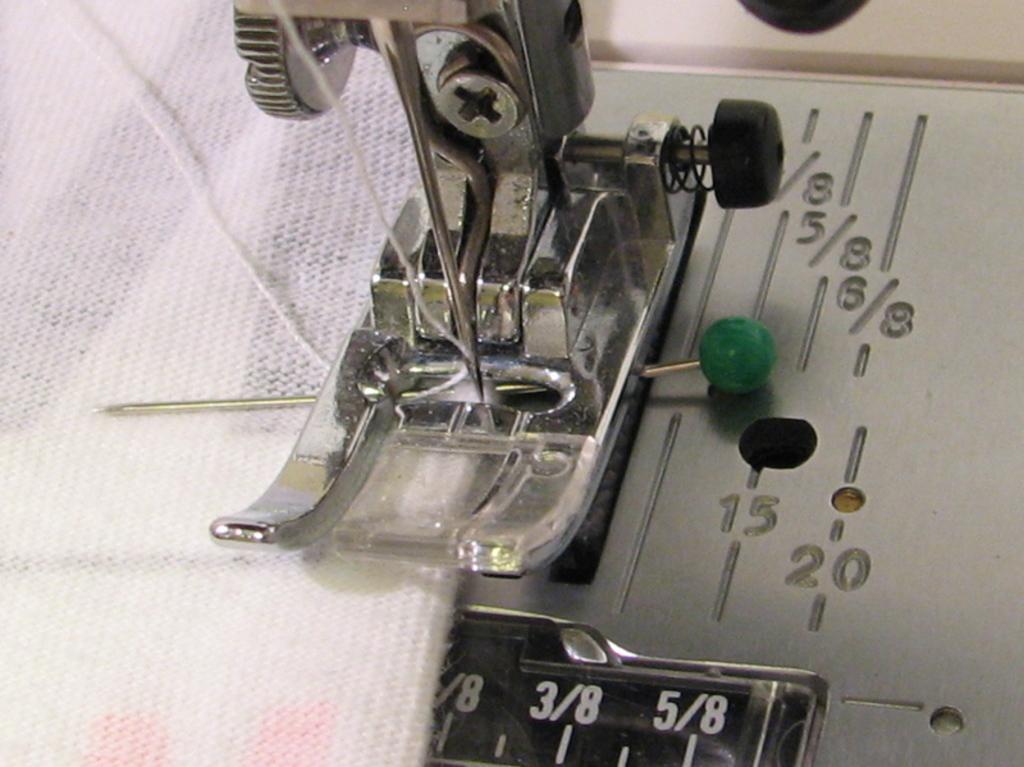Describe this image in one or two sentences. In this image we can see a machine tool. We can also see a pin, cloth, some numbers and a thread. 